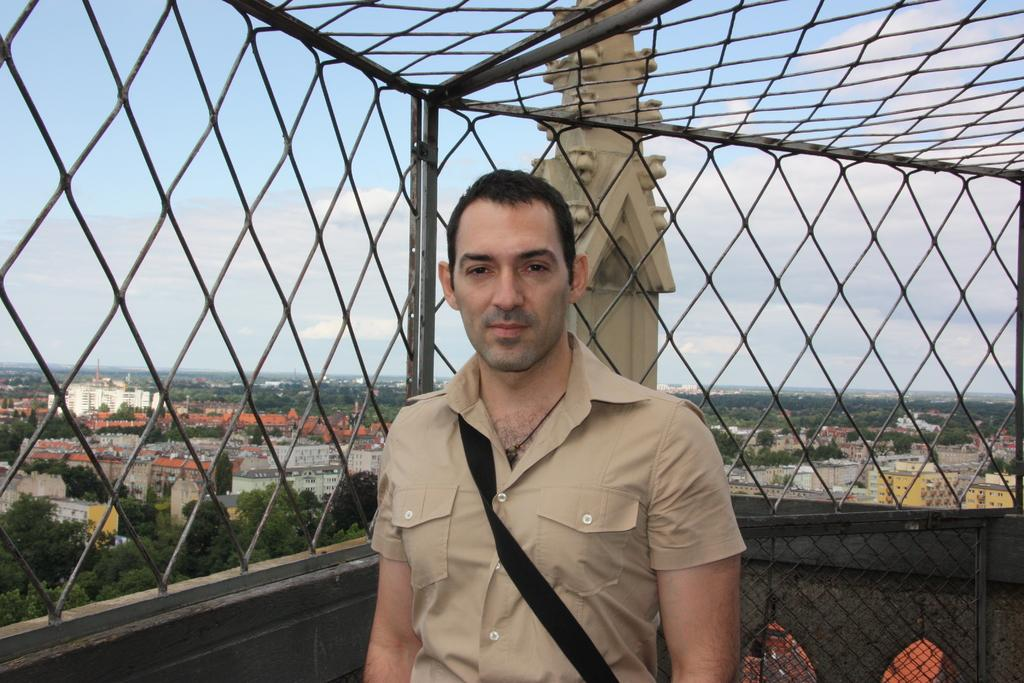What is the main subject of the image? There is a person standing in the image. What is located behind the person? There is a fence behind the person. What can be seen in the distance in the image? There are trees and buildings in the background of the image. Can you see the ocean in the background of the image? No, the ocean is not visible in the image; there are only trees and buildings in the background. 